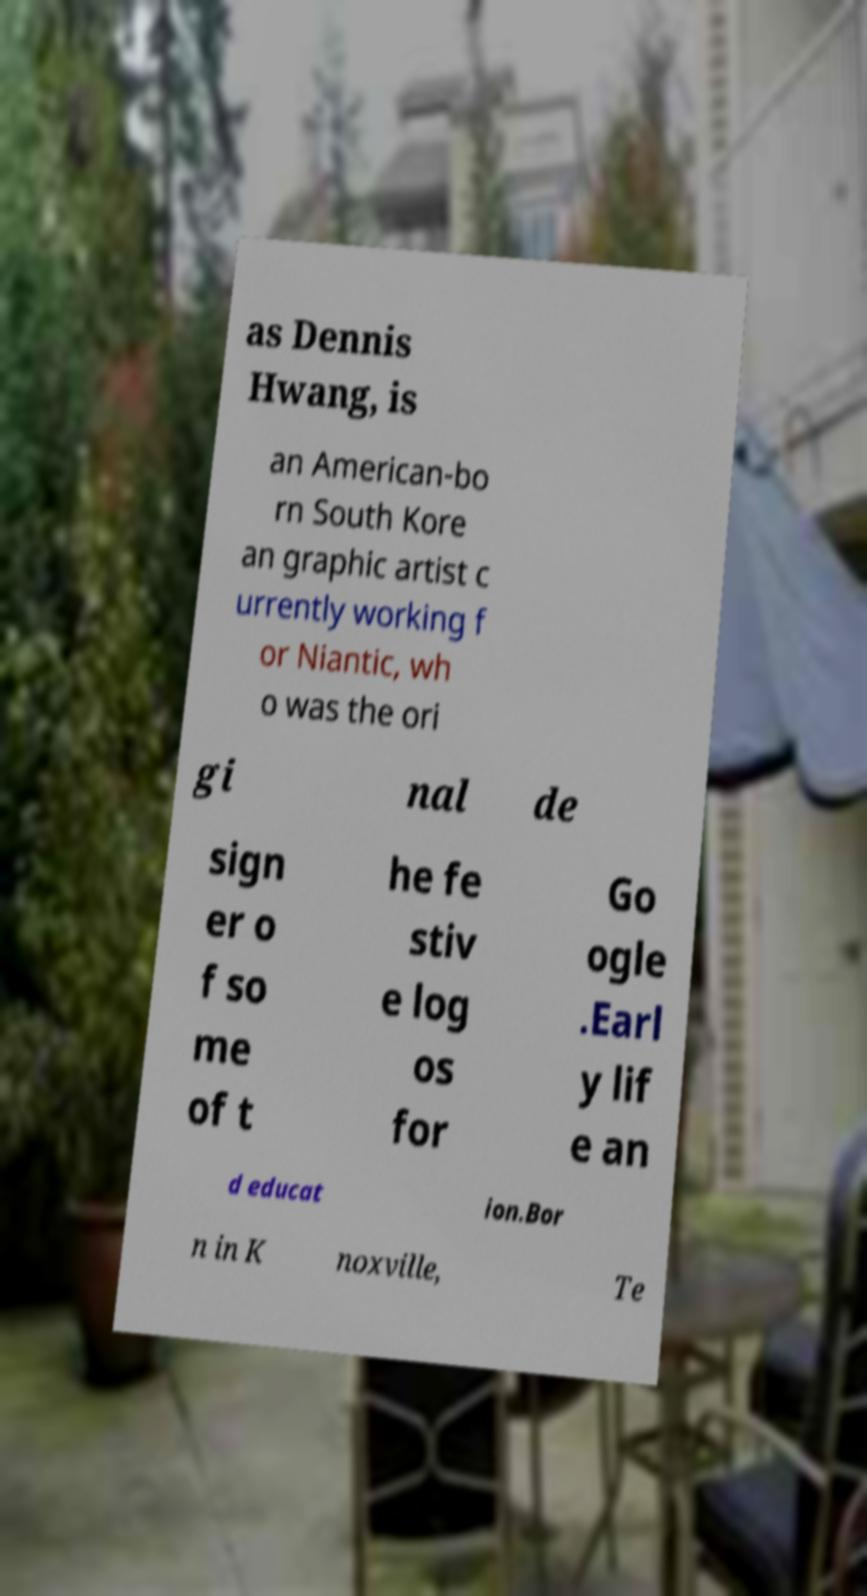I need the written content from this picture converted into text. Can you do that? as Dennis Hwang, is an American-bo rn South Kore an graphic artist c urrently working f or Niantic, wh o was the ori gi nal de sign er o f so me of t he fe stiv e log os for Go ogle .Earl y lif e an d educat ion.Bor n in K noxville, Te 